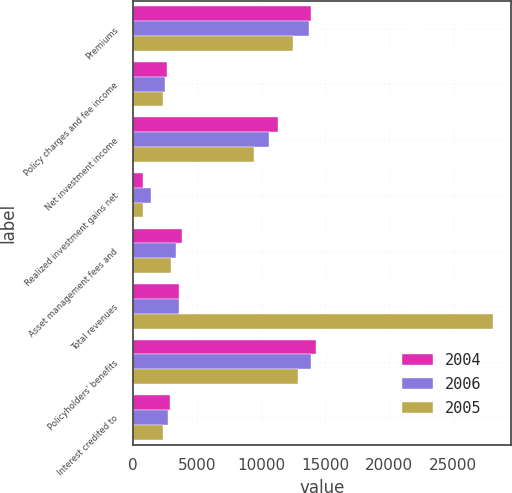Convert chart. <chart><loc_0><loc_0><loc_500><loc_500><stacked_bar_chart><ecel><fcel>Premiums<fcel>Policy charges and fee income<fcel>Net investment income<fcel>Realized investment gains net<fcel>Asset management fees and<fcel>Total revenues<fcel>Policyholders' benefits<fcel>Interest credited to<nl><fcel>2004<fcel>13908<fcel>2653<fcel>11354<fcel>774<fcel>3799<fcel>3573.5<fcel>14283<fcel>2917<nl><fcel>2006<fcel>13756<fcel>2520<fcel>10597<fcel>1378<fcel>3348<fcel>3573.5<fcel>13883<fcel>2699<nl><fcel>2005<fcel>12521<fcel>2342<fcel>9455<fcel>778<fcel>3000<fcel>28096<fcel>12863<fcel>2359<nl></chart> 